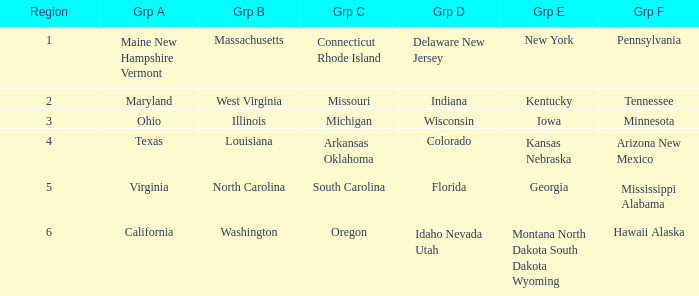Which region belongs to group c when illinois is part of group b? Michigan. 